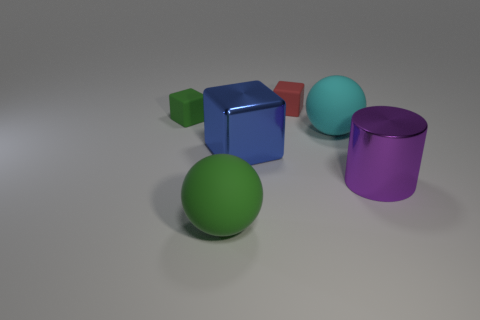The small object that is right of the small green block is what color?
Provide a short and direct response. Red. Is there a matte thing in front of the tiny thing behind the tiny green object?
Your response must be concise. Yes. What number of other objects are there of the same color as the cylinder?
Keep it short and to the point. 0. Do the ball that is right of the red rubber cube and the metal cylinder on the right side of the red matte block have the same size?
Make the answer very short. Yes. What is the size of the cube left of the cube that is in front of the tiny green thing?
Offer a terse response. Small. There is a big thing that is both left of the tiny red matte thing and behind the big green sphere; what material is it?
Give a very brief answer. Metal. What color is the big cylinder?
Your response must be concise. Purple. Is there any other thing that is made of the same material as the green block?
Give a very brief answer. Yes. What is the shape of the large blue shiny object to the left of the red thing?
Give a very brief answer. Cube. Is there a metal cylinder in front of the sphere to the left of the large sphere that is to the right of the big cube?
Provide a short and direct response. No. 